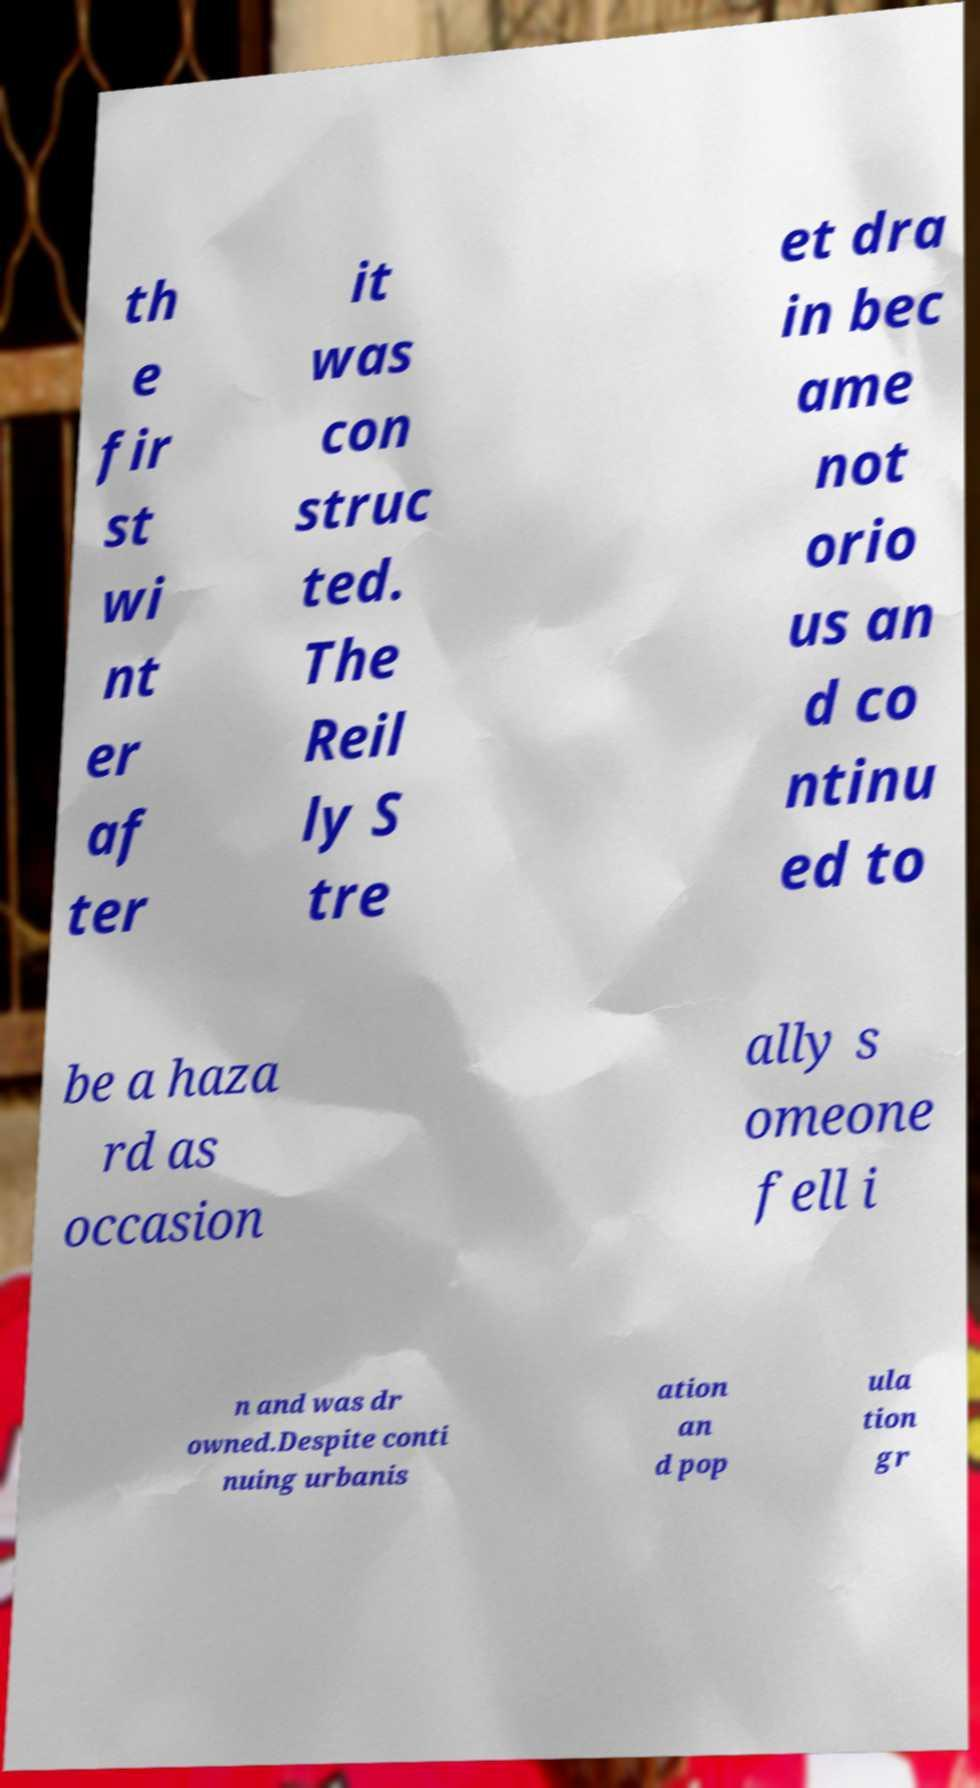Can you read and provide the text displayed in the image?This photo seems to have some interesting text. Can you extract and type it out for me? th e fir st wi nt er af ter it was con struc ted. The Reil ly S tre et dra in bec ame not orio us an d co ntinu ed to be a haza rd as occasion ally s omeone fell i n and was dr owned.Despite conti nuing urbanis ation an d pop ula tion gr 